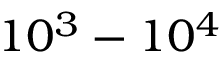Convert formula to latex. <formula><loc_0><loc_0><loc_500><loc_500>1 0 ^ { 3 } - 1 0 ^ { 4 }</formula> 